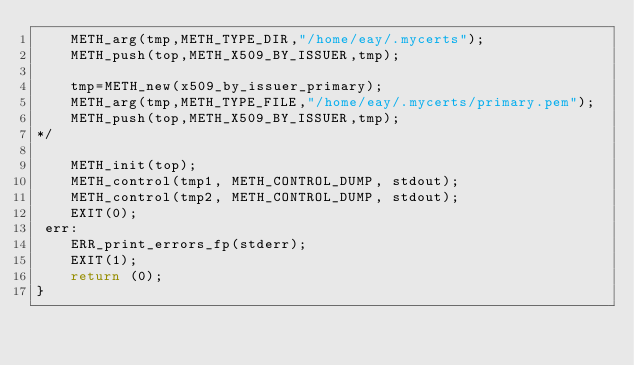<code> <loc_0><loc_0><loc_500><loc_500><_C_>    METH_arg(tmp,METH_TYPE_DIR,"/home/eay/.mycerts");
    METH_push(top,METH_X509_BY_ISSUER,tmp);

    tmp=METH_new(x509_by_issuer_primary);
    METH_arg(tmp,METH_TYPE_FILE,"/home/eay/.mycerts/primary.pem");
    METH_push(top,METH_X509_BY_ISSUER,tmp);
*/

    METH_init(top);
    METH_control(tmp1, METH_CONTROL_DUMP, stdout);
    METH_control(tmp2, METH_CONTROL_DUMP, stdout);
    EXIT(0);
 err:
    ERR_print_errors_fp(stderr);
    EXIT(1);
    return (0);
}
</code> 